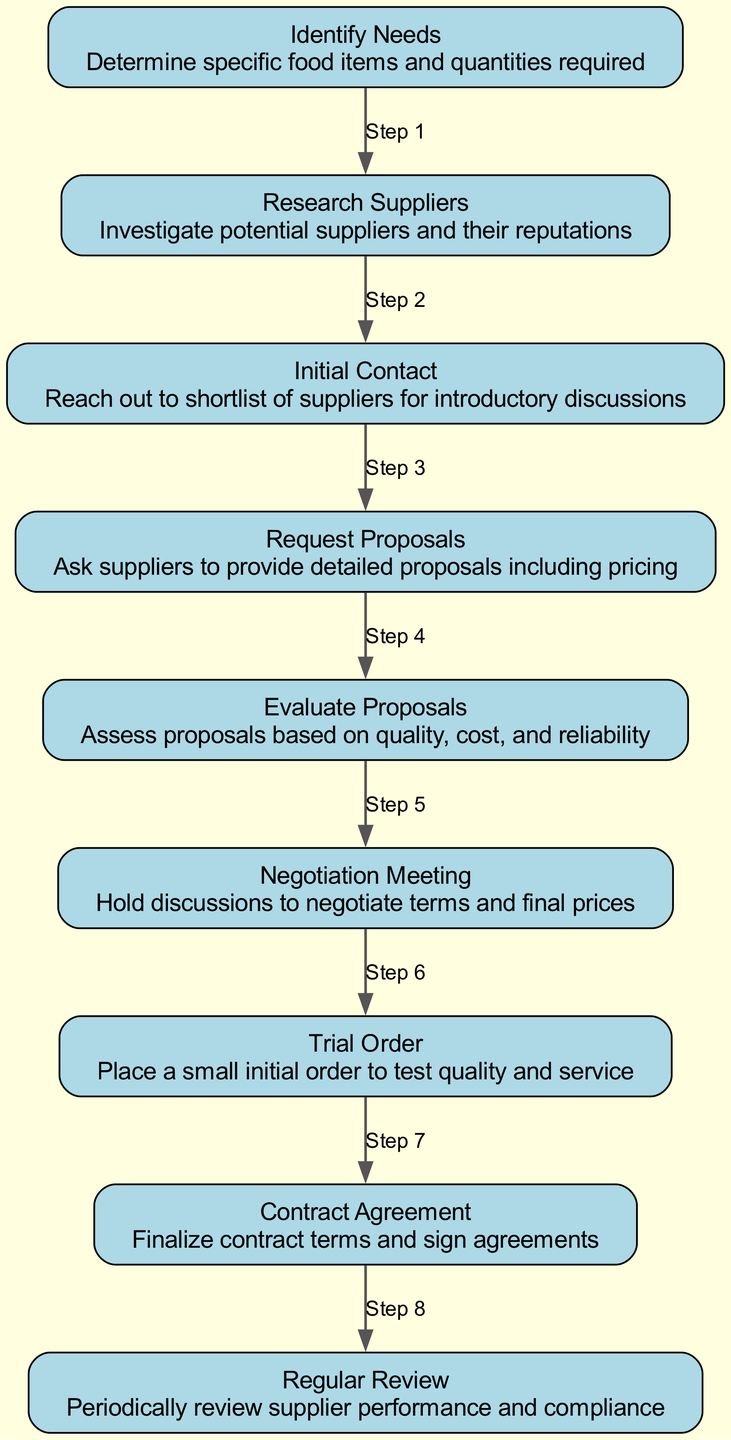What is the first step in the flowchart? The flowchart outlines the steps starting with "Identify Needs," indicating the first action to determine specific food items and quantities required.
Answer: Identify Needs How many nodes are present in the flowchart? The flowchart contains a total of 9 nodes, each representing a different step in the supplier relationship process.
Answer: 9 Which node follows "Initial Contact"? After "Initial Contact," the next node is "Request Proposals," which entails asking suppliers to provide detailed proposals including pricing.
Answer: Request Proposals What is the label of the last node in the flowchart? The final node listed in the flowchart is "Regular Review," which signifies the periodic assessment of supplier performance and compliance.
Answer: Regular Review What is the relationship between "Evaluate Proposals" and "Negotiation Meeting"? The relationship indicates a sequential step, where "Evaluate Proposals" leads directly to "Negotiation Meeting," which is the next phase in discussing terms and final prices.
Answer: Step 5 How many edges connect the nodes in the flowchart? The flowchart has a total of 8 edges, which demonstrate the connections and progression between the different nodes or steps in the process.
Answer: 8 Which step is associated with placing a small initial order? The step corresponding to placing a small initial order is "Trial Order," which allows testing the supplier's quality and service.
Answer: Trial Order What is the purpose of the "Contract Agreement" node? The "Contract Agreement" node's purpose is to finalize and sign the terms of contract agreements with selected suppliers after negotiations have concluded.
Answer: Finalize contract terms Which node describes the importance of small initial orders? The node "Trial Order" describes the importance of placing small initial orders to test the quality and service of the suppliers chosen.
Answer: Trial Order 